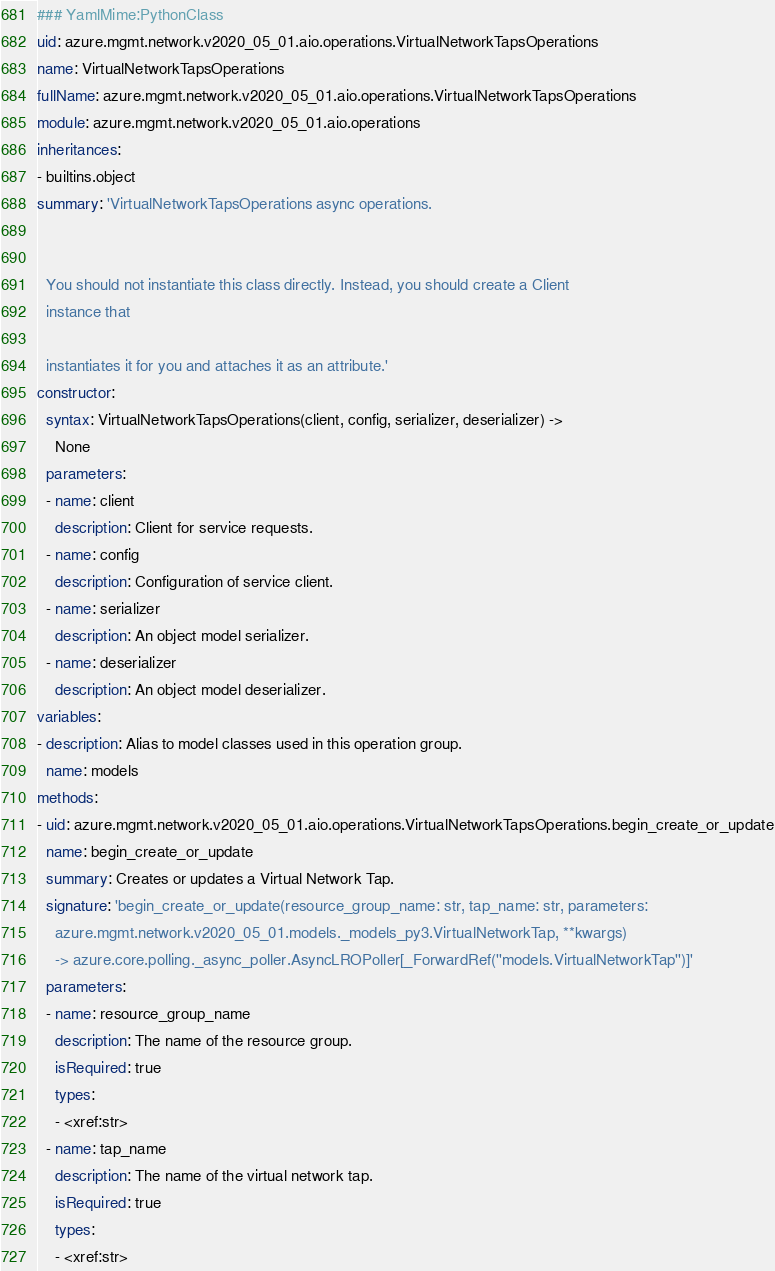Convert code to text. <code><loc_0><loc_0><loc_500><loc_500><_YAML_>### YamlMime:PythonClass
uid: azure.mgmt.network.v2020_05_01.aio.operations.VirtualNetworkTapsOperations
name: VirtualNetworkTapsOperations
fullName: azure.mgmt.network.v2020_05_01.aio.operations.VirtualNetworkTapsOperations
module: azure.mgmt.network.v2020_05_01.aio.operations
inheritances:
- builtins.object
summary: 'VirtualNetworkTapsOperations async operations.


  You should not instantiate this class directly. Instead, you should create a Client
  instance that

  instantiates it for you and attaches it as an attribute.'
constructor:
  syntax: VirtualNetworkTapsOperations(client, config, serializer, deserializer) ->
    None
  parameters:
  - name: client
    description: Client for service requests.
  - name: config
    description: Configuration of service client.
  - name: serializer
    description: An object model serializer.
  - name: deserializer
    description: An object model deserializer.
variables:
- description: Alias to model classes used in this operation group.
  name: models
methods:
- uid: azure.mgmt.network.v2020_05_01.aio.operations.VirtualNetworkTapsOperations.begin_create_or_update
  name: begin_create_or_update
  summary: Creates or updates a Virtual Network Tap.
  signature: 'begin_create_or_update(resource_group_name: str, tap_name: str, parameters:
    azure.mgmt.network.v2020_05_01.models._models_py3.VirtualNetworkTap, **kwargs)
    -> azure.core.polling._async_poller.AsyncLROPoller[_ForwardRef(''models.VirtualNetworkTap'')]'
  parameters:
  - name: resource_group_name
    description: The name of the resource group.
    isRequired: true
    types:
    - <xref:str>
  - name: tap_name
    description: The name of the virtual network tap.
    isRequired: true
    types:
    - <xref:str></code> 